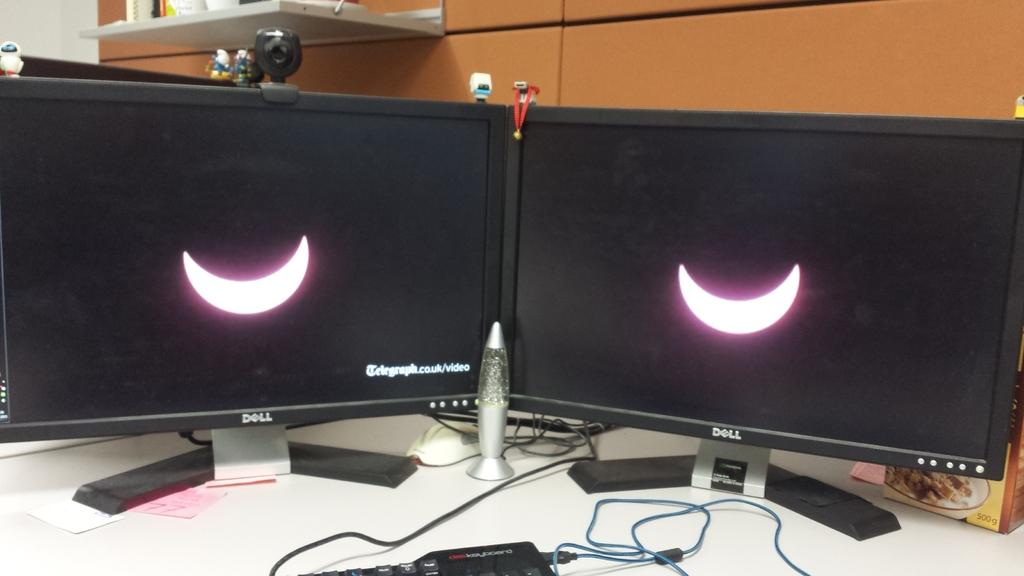<image>
Describe the image concisely. a screen with the word telegraph on it 